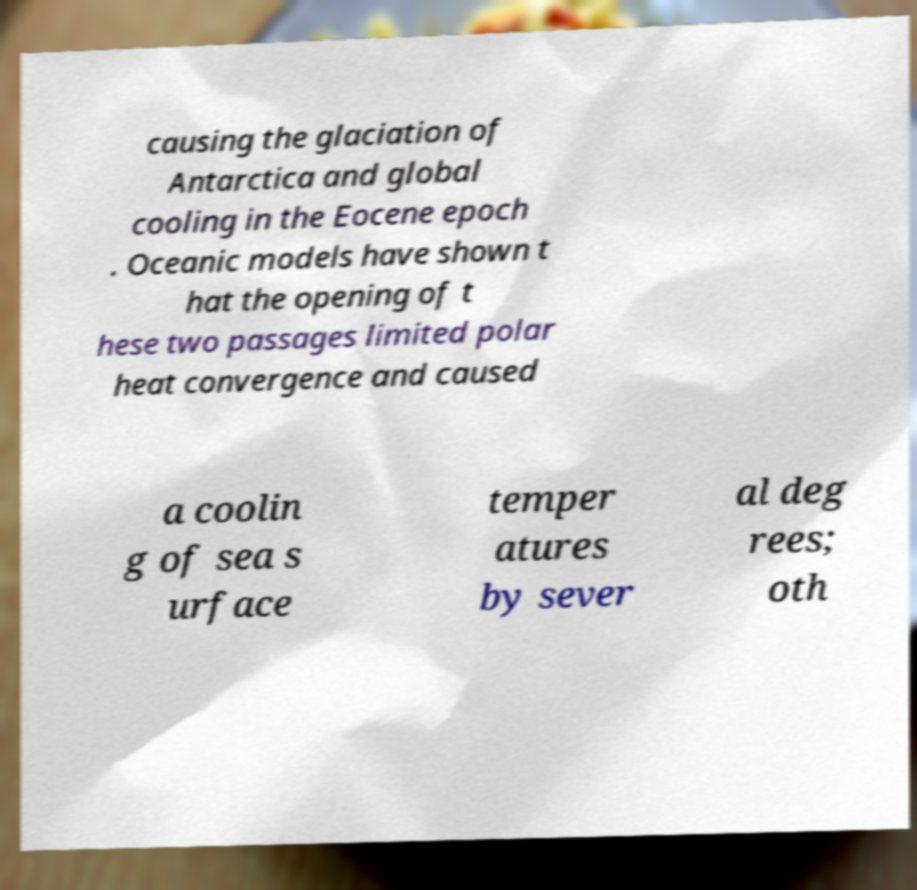Could you extract and type out the text from this image? causing the glaciation of Antarctica and global cooling in the Eocene epoch . Oceanic models have shown t hat the opening of t hese two passages limited polar heat convergence and caused a coolin g of sea s urface temper atures by sever al deg rees; oth 